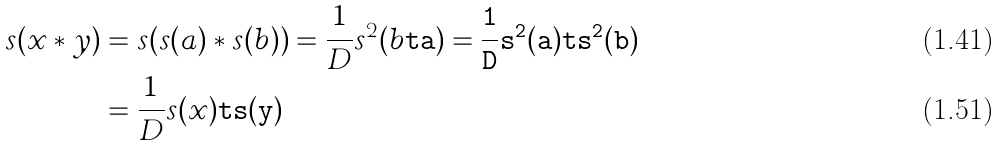<formula> <loc_0><loc_0><loc_500><loc_500>s ( x * y ) & = s ( s ( a ) * s ( b ) ) = \frac { 1 } { D } s ^ { 2 } ( b \tt t a ) = \frac { 1 } { D } s ^ { 2 } ( a ) \tt t s ^ { 2 } ( b ) \\ & = \frac { 1 } { D } s ( x ) \tt t s ( y )</formula> 